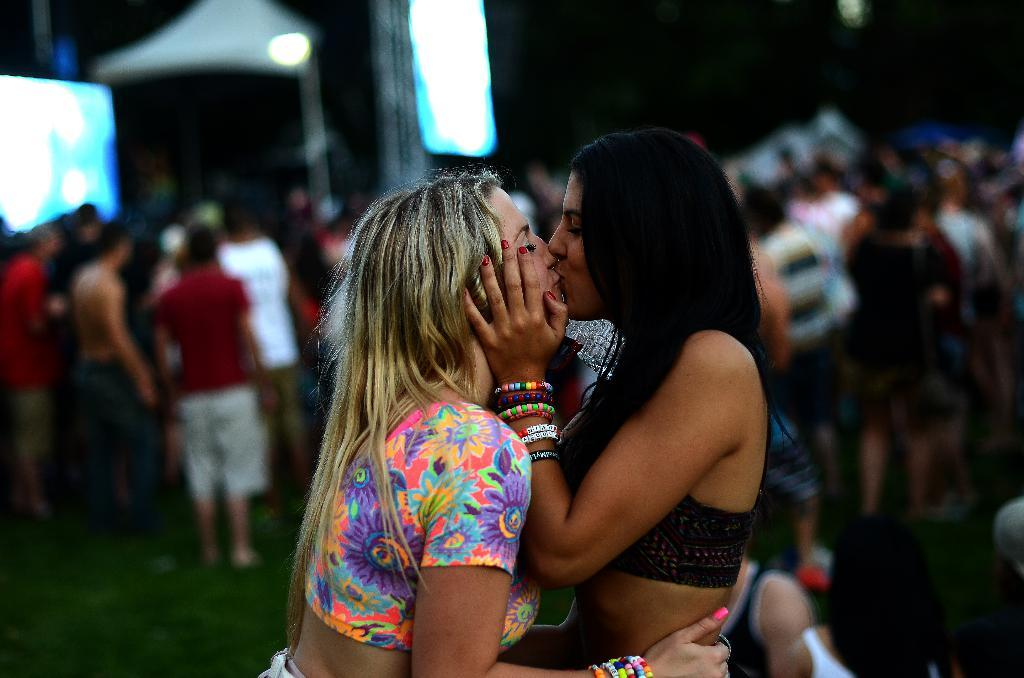How many people are in the image? There are two women in the image. What are the women doing in the image? The women are kissing each other. Can you describe the background of the image? The background of the image is blurry. What else can be seen in the background besides the blurriness? There are people and objects visible in the background. Is there steam coming from the connection between the two women in the image? There is no steam present in the image, nor is there a connection between the two women that could produce steam. 